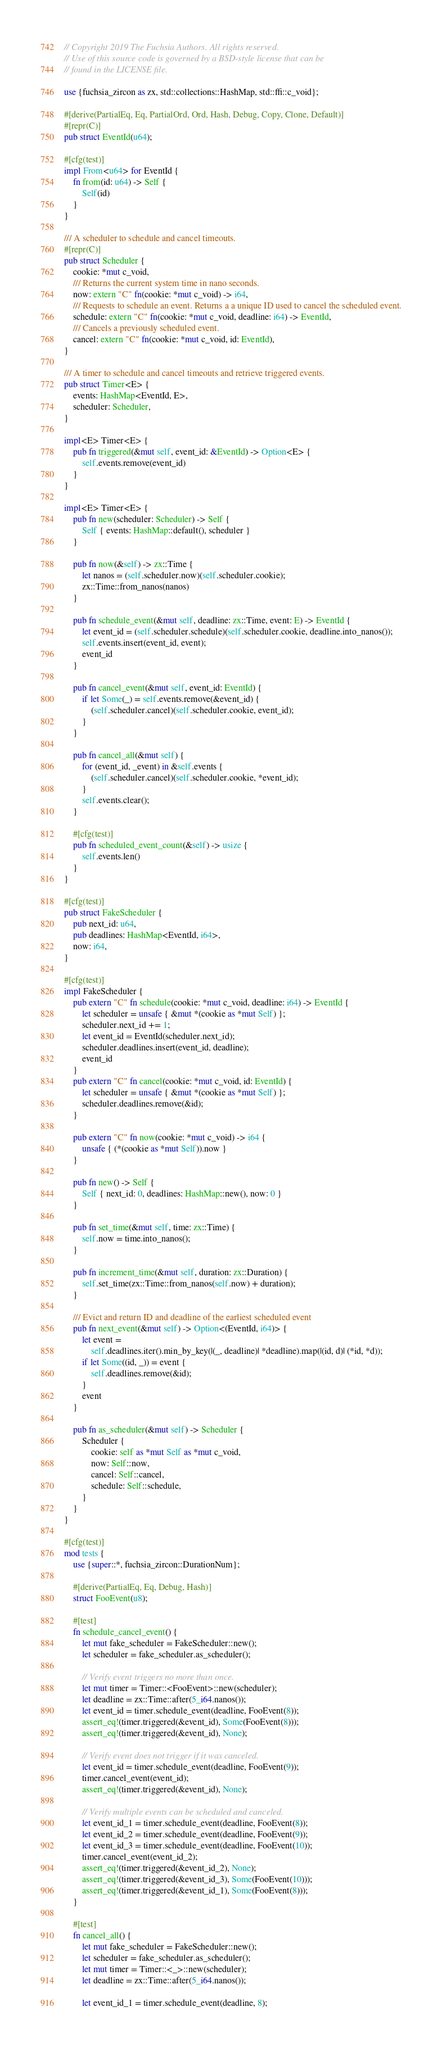Convert code to text. <code><loc_0><loc_0><loc_500><loc_500><_Rust_>// Copyright 2019 The Fuchsia Authors. All rights reserved.
// Use of this source code is governed by a BSD-style license that can be
// found in the LICENSE file.

use {fuchsia_zircon as zx, std::collections::HashMap, std::ffi::c_void};

#[derive(PartialEq, Eq, PartialOrd, Ord, Hash, Debug, Copy, Clone, Default)]
#[repr(C)]
pub struct EventId(u64);

#[cfg(test)]
impl From<u64> for EventId {
    fn from(id: u64) -> Self {
        Self(id)
    }
}

/// A scheduler to schedule and cancel timeouts.
#[repr(C)]
pub struct Scheduler {
    cookie: *mut c_void,
    /// Returns the current system time in nano seconds.
    now: extern "C" fn(cookie: *mut c_void) -> i64,
    /// Requests to schedule an event. Returns a a unique ID used to cancel the scheduled event.
    schedule: extern "C" fn(cookie: *mut c_void, deadline: i64) -> EventId,
    /// Cancels a previously scheduled event.
    cancel: extern "C" fn(cookie: *mut c_void, id: EventId),
}

/// A timer to schedule and cancel timeouts and retrieve triggered events.
pub struct Timer<E> {
    events: HashMap<EventId, E>,
    scheduler: Scheduler,
}

impl<E> Timer<E> {
    pub fn triggered(&mut self, event_id: &EventId) -> Option<E> {
        self.events.remove(event_id)
    }
}

impl<E> Timer<E> {
    pub fn new(scheduler: Scheduler) -> Self {
        Self { events: HashMap::default(), scheduler }
    }

    pub fn now(&self) -> zx::Time {
        let nanos = (self.scheduler.now)(self.scheduler.cookie);
        zx::Time::from_nanos(nanos)
    }

    pub fn schedule_event(&mut self, deadline: zx::Time, event: E) -> EventId {
        let event_id = (self.scheduler.schedule)(self.scheduler.cookie, deadline.into_nanos());
        self.events.insert(event_id, event);
        event_id
    }

    pub fn cancel_event(&mut self, event_id: EventId) {
        if let Some(_) = self.events.remove(&event_id) {
            (self.scheduler.cancel)(self.scheduler.cookie, event_id);
        }
    }

    pub fn cancel_all(&mut self) {
        for (event_id, _event) in &self.events {
            (self.scheduler.cancel)(self.scheduler.cookie, *event_id);
        }
        self.events.clear();
    }

    #[cfg(test)]
    pub fn scheduled_event_count(&self) -> usize {
        self.events.len()
    }
}

#[cfg(test)]
pub struct FakeScheduler {
    pub next_id: u64,
    pub deadlines: HashMap<EventId, i64>,
    now: i64,
}

#[cfg(test)]
impl FakeScheduler {
    pub extern "C" fn schedule(cookie: *mut c_void, deadline: i64) -> EventId {
        let scheduler = unsafe { &mut *(cookie as *mut Self) };
        scheduler.next_id += 1;
        let event_id = EventId(scheduler.next_id);
        scheduler.deadlines.insert(event_id, deadline);
        event_id
    }
    pub extern "C" fn cancel(cookie: *mut c_void, id: EventId) {
        let scheduler = unsafe { &mut *(cookie as *mut Self) };
        scheduler.deadlines.remove(&id);
    }

    pub extern "C" fn now(cookie: *mut c_void) -> i64 {
        unsafe { (*(cookie as *mut Self)).now }
    }

    pub fn new() -> Self {
        Self { next_id: 0, deadlines: HashMap::new(), now: 0 }
    }

    pub fn set_time(&mut self, time: zx::Time) {
        self.now = time.into_nanos();
    }

    pub fn increment_time(&mut self, duration: zx::Duration) {
        self.set_time(zx::Time::from_nanos(self.now) + duration);
    }

    /// Evict and return ID and deadline of the earliest scheduled event
    pub fn next_event(&mut self) -> Option<(EventId, i64)> {
        let event =
            self.deadlines.iter().min_by_key(|(_, deadline)| *deadline).map(|(id, d)| (*id, *d));
        if let Some((id, _)) = event {
            self.deadlines.remove(&id);
        }
        event
    }

    pub fn as_scheduler(&mut self) -> Scheduler {
        Scheduler {
            cookie: self as *mut Self as *mut c_void,
            now: Self::now,
            cancel: Self::cancel,
            schedule: Self::schedule,
        }
    }
}

#[cfg(test)]
mod tests {
    use {super::*, fuchsia_zircon::DurationNum};

    #[derive(PartialEq, Eq, Debug, Hash)]
    struct FooEvent(u8);

    #[test]
    fn schedule_cancel_event() {
        let mut fake_scheduler = FakeScheduler::new();
        let scheduler = fake_scheduler.as_scheduler();

        // Verify event triggers no more than once.
        let mut timer = Timer::<FooEvent>::new(scheduler);
        let deadline = zx::Time::after(5_i64.nanos());
        let event_id = timer.schedule_event(deadline, FooEvent(8));
        assert_eq!(timer.triggered(&event_id), Some(FooEvent(8)));
        assert_eq!(timer.triggered(&event_id), None);

        // Verify event does not trigger if it was canceled.
        let event_id = timer.schedule_event(deadline, FooEvent(9));
        timer.cancel_event(event_id);
        assert_eq!(timer.triggered(&event_id), None);

        // Verify multiple events can be scheduled and canceled.
        let event_id_1 = timer.schedule_event(deadline, FooEvent(8));
        let event_id_2 = timer.schedule_event(deadline, FooEvent(9));
        let event_id_3 = timer.schedule_event(deadline, FooEvent(10));
        timer.cancel_event(event_id_2);
        assert_eq!(timer.triggered(&event_id_2), None);
        assert_eq!(timer.triggered(&event_id_3), Some(FooEvent(10)));
        assert_eq!(timer.triggered(&event_id_1), Some(FooEvent(8)));
    }

    #[test]
    fn cancel_all() {
        let mut fake_scheduler = FakeScheduler::new();
        let scheduler = fake_scheduler.as_scheduler();
        let mut timer = Timer::<_>::new(scheduler);
        let deadline = zx::Time::after(5_i64.nanos());

        let event_id_1 = timer.schedule_event(deadline, 8);</code> 